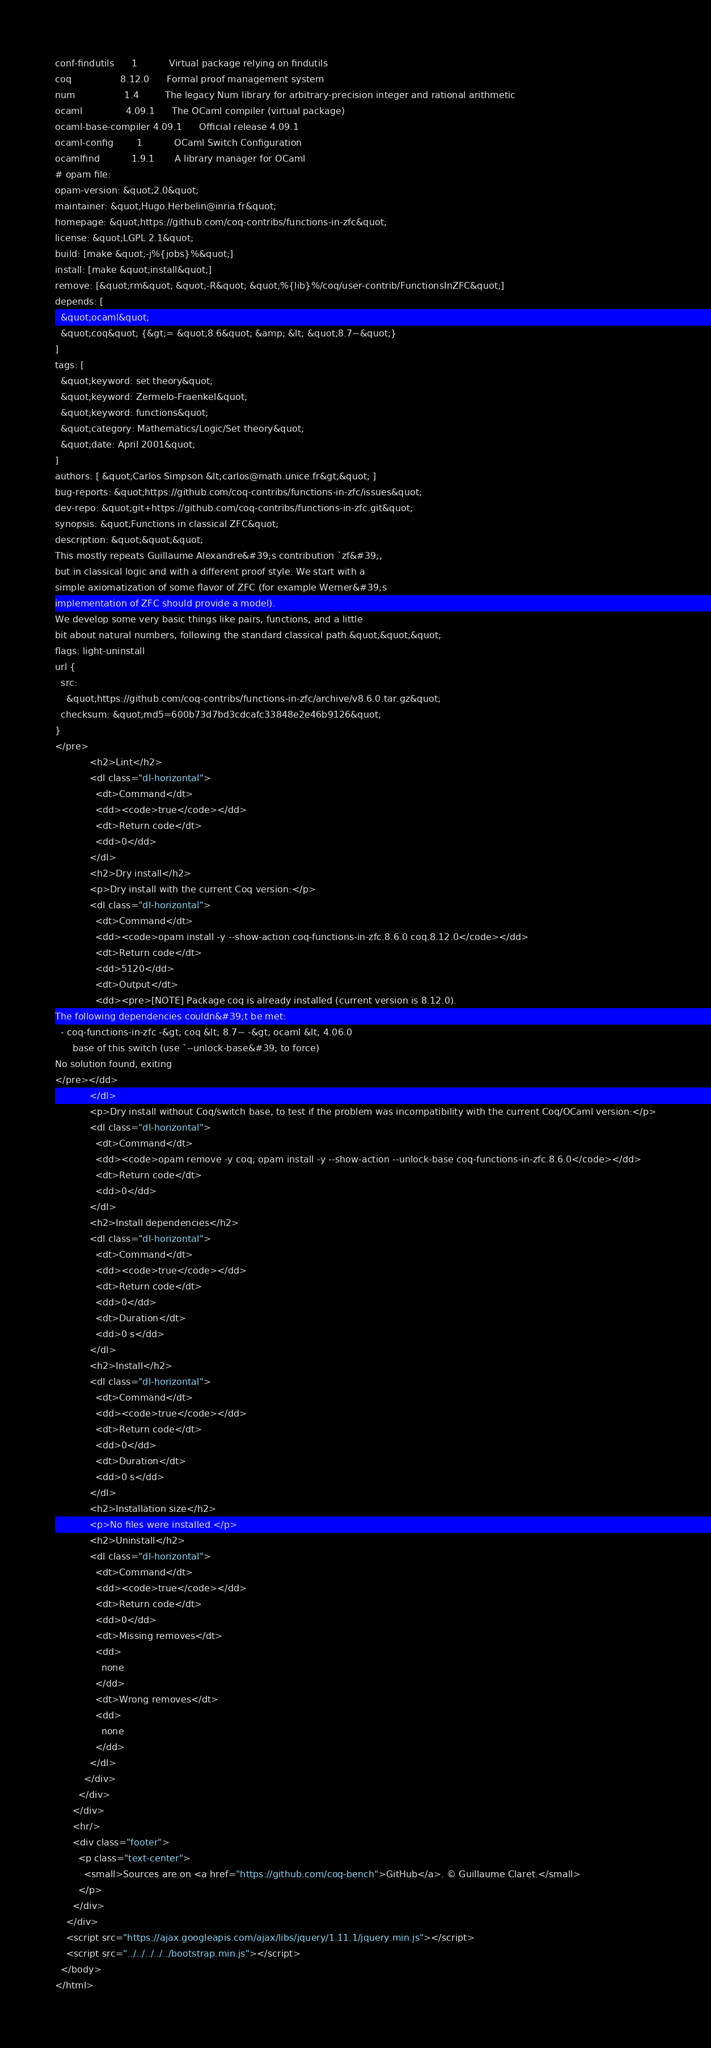Convert code to text. <code><loc_0><loc_0><loc_500><loc_500><_HTML_>conf-findutils      1           Virtual package relying on findutils
coq                 8.12.0      Formal proof management system
num                 1.4         The legacy Num library for arbitrary-precision integer and rational arithmetic
ocaml               4.09.1      The OCaml compiler (virtual package)
ocaml-base-compiler 4.09.1      Official release 4.09.1
ocaml-config        1           OCaml Switch Configuration
ocamlfind           1.9.1       A library manager for OCaml
# opam file:
opam-version: &quot;2.0&quot;
maintainer: &quot;Hugo.Herbelin@inria.fr&quot;
homepage: &quot;https://github.com/coq-contribs/functions-in-zfc&quot;
license: &quot;LGPL 2.1&quot;
build: [make &quot;-j%{jobs}%&quot;]
install: [make &quot;install&quot;]
remove: [&quot;rm&quot; &quot;-R&quot; &quot;%{lib}%/coq/user-contrib/FunctionsInZFC&quot;]
depends: [
  &quot;ocaml&quot;
  &quot;coq&quot; {&gt;= &quot;8.6&quot; &amp; &lt; &quot;8.7~&quot;}
]
tags: [
  &quot;keyword: set theory&quot;
  &quot;keyword: Zermelo-Fraenkel&quot;
  &quot;keyword: functions&quot;
  &quot;category: Mathematics/Logic/Set theory&quot;
  &quot;date: April 2001&quot;
]
authors: [ &quot;Carlos Simpson &lt;carlos@math.unice.fr&gt;&quot; ]
bug-reports: &quot;https://github.com/coq-contribs/functions-in-zfc/issues&quot;
dev-repo: &quot;git+https://github.com/coq-contribs/functions-in-zfc.git&quot;
synopsis: &quot;Functions in classical ZFC&quot;
description: &quot;&quot;&quot;
This mostly repeats Guillaume Alexandre&#39;s contribution `zf&#39;,
but in classical logic and with a different proof style. We start with a
simple axiomatization of some flavor of ZFC (for example Werner&#39;s
implementation of ZFC should provide a model).
We develop some very basic things like pairs, functions, and a little
bit about natural numbers, following the standard classical path.&quot;&quot;&quot;
flags: light-uninstall
url {
  src:
    &quot;https://github.com/coq-contribs/functions-in-zfc/archive/v8.6.0.tar.gz&quot;
  checksum: &quot;md5=600b73d7bd3cdcafc33848e2e46b9126&quot;
}
</pre>
            <h2>Lint</h2>
            <dl class="dl-horizontal">
              <dt>Command</dt>
              <dd><code>true</code></dd>
              <dt>Return code</dt>
              <dd>0</dd>
            </dl>
            <h2>Dry install</h2>
            <p>Dry install with the current Coq version:</p>
            <dl class="dl-horizontal">
              <dt>Command</dt>
              <dd><code>opam install -y --show-action coq-functions-in-zfc.8.6.0 coq.8.12.0</code></dd>
              <dt>Return code</dt>
              <dd>5120</dd>
              <dt>Output</dt>
              <dd><pre>[NOTE] Package coq is already installed (current version is 8.12.0).
The following dependencies couldn&#39;t be met:
  - coq-functions-in-zfc -&gt; coq &lt; 8.7~ -&gt; ocaml &lt; 4.06.0
      base of this switch (use `--unlock-base&#39; to force)
No solution found, exiting
</pre></dd>
            </dl>
            <p>Dry install without Coq/switch base, to test if the problem was incompatibility with the current Coq/OCaml version:</p>
            <dl class="dl-horizontal">
              <dt>Command</dt>
              <dd><code>opam remove -y coq; opam install -y --show-action --unlock-base coq-functions-in-zfc.8.6.0</code></dd>
              <dt>Return code</dt>
              <dd>0</dd>
            </dl>
            <h2>Install dependencies</h2>
            <dl class="dl-horizontal">
              <dt>Command</dt>
              <dd><code>true</code></dd>
              <dt>Return code</dt>
              <dd>0</dd>
              <dt>Duration</dt>
              <dd>0 s</dd>
            </dl>
            <h2>Install</h2>
            <dl class="dl-horizontal">
              <dt>Command</dt>
              <dd><code>true</code></dd>
              <dt>Return code</dt>
              <dd>0</dd>
              <dt>Duration</dt>
              <dd>0 s</dd>
            </dl>
            <h2>Installation size</h2>
            <p>No files were installed.</p>
            <h2>Uninstall</h2>
            <dl class="dl-horizontal">
              <dt>Command</dt>
              <dd><code>true</code></dd>
              <dt>Return code</dt>
              <dd>0</dd>
              <dt>Missing removes</dt>
              <dd>
                none
              </dd>
              <dt>Wrong removes</dt>
              <dd>
                none
              </dd>
            </dl>
          </div>
        </div>
      </div>
      <hr/>
      <div class="footer">
        <p class="text-center">
          <small>Sources are on <a href="https://github.com/coq-bench">GitHub</a>. © Guillaume Claret.</small>
        </p>
      </div>
    </div>
    <script src="https://ajax.googleapis.com/ajax/libs/jquery/1.11.1/jquery.min.js"></script>
    <script src="../../../../../bootstrap.min.js"></script>
  </body>
</html>
</code> 